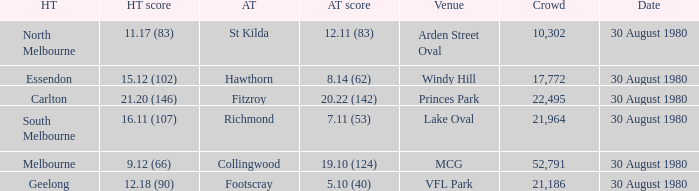What was the score for south melbourne at home? 16.11 (107). 